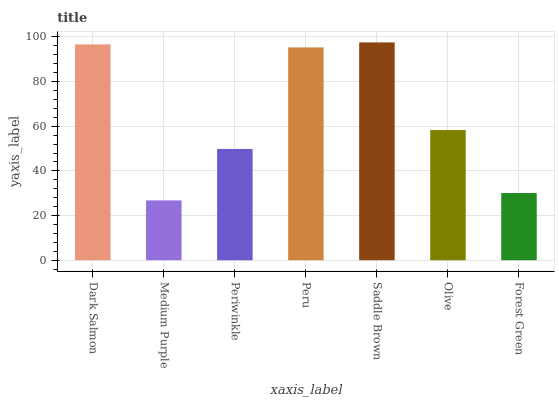Is Periwinkle the minimum?
Answer yes or no. No. Is Periwinkle the maximum?
Answer yes or no. No. Is Periwinkle greater than Medium Purple?
Answer yes or no. Yes. Is Medium Purple less than Periwinkle?
Answer yes or no. Yes. Is Medium Purple greater than Periwinkle?
Answer yes or no. No. Is Periwinkle less than Medium Purple?
Answer yes or no. No. Is Olive the high median?
Answer yes or no. Yes. Is Olive the low median?
Answer yes or no. Yes. Is Periwinkle the high median?
Answer yes or no. No. Is Saddle Brown the low median?
Answer yes or no. No. 